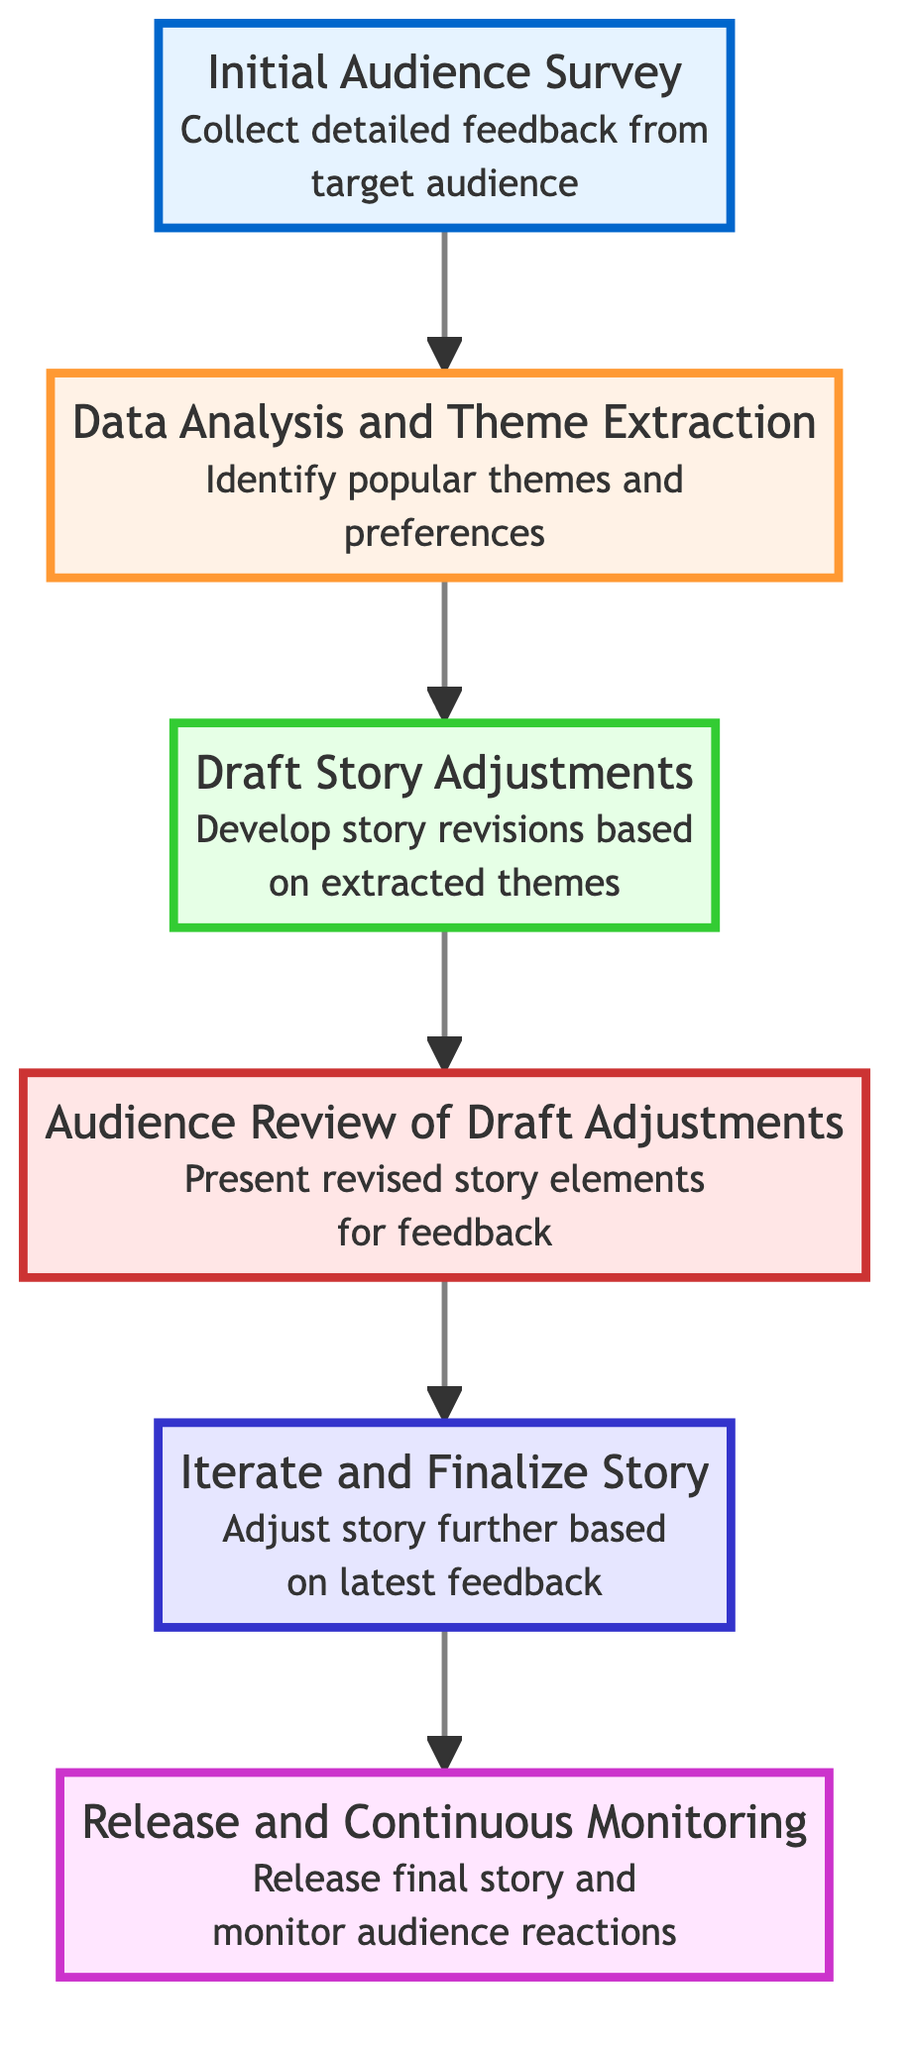What is the first node in the flow chart? The first node is labeled "Initial Audience Survey," which is the entry point of the flow chart, representing the starting step of the process.
Answer: Initial Audience Survey How many nodes are in the diagram? There are a total of six distinct nodes in the flow chart, each representing a step in the story adjustment process.
Answer: 6 What does the second node represent? The second node is labeled "Data Analysis and Theme Extraction," indicating the step where survey data is analyzed for themes and preferences.
Answer: Data Analysis and Theme Extraction Which process comes after "Draft Story Adjustments"? After "Draft Story Adjustments," the next process is "Audience Review of Draft Adjustments," where the draft adjustments are reviewed by the audience for feedback.
Answer: Audience Review of Draft Adjustments What is the final step in the diagram? The final step in the flow chart is labeled "Release and Continuous Monitoring," which represents the release of the finalized story and the continuous monitoring of feedback.
Answer: Release and Continuous Monitoring What do we do after "Audience Review of Draft Adjustments"? After "Audience Review of Draft Adjustments," the diagram indicates that we "Iterate and Finalize Story" based on the feedback received from the audience review.
Answer: Iterate and Finalize Story Which step involves collecting feedback from the target audience? The step labeled "Initial Audience Survey" involves collecting detailed feedback from the target audience through various methods.
Answer: Initial Audience Survey How does the flow chart move from bottom to top? The flow chart illustrates a bottom-to-top progression by having each node point upwards to the next step in the process, indicating the flow of actions from initial survey to final release.
Answer: Upwards 